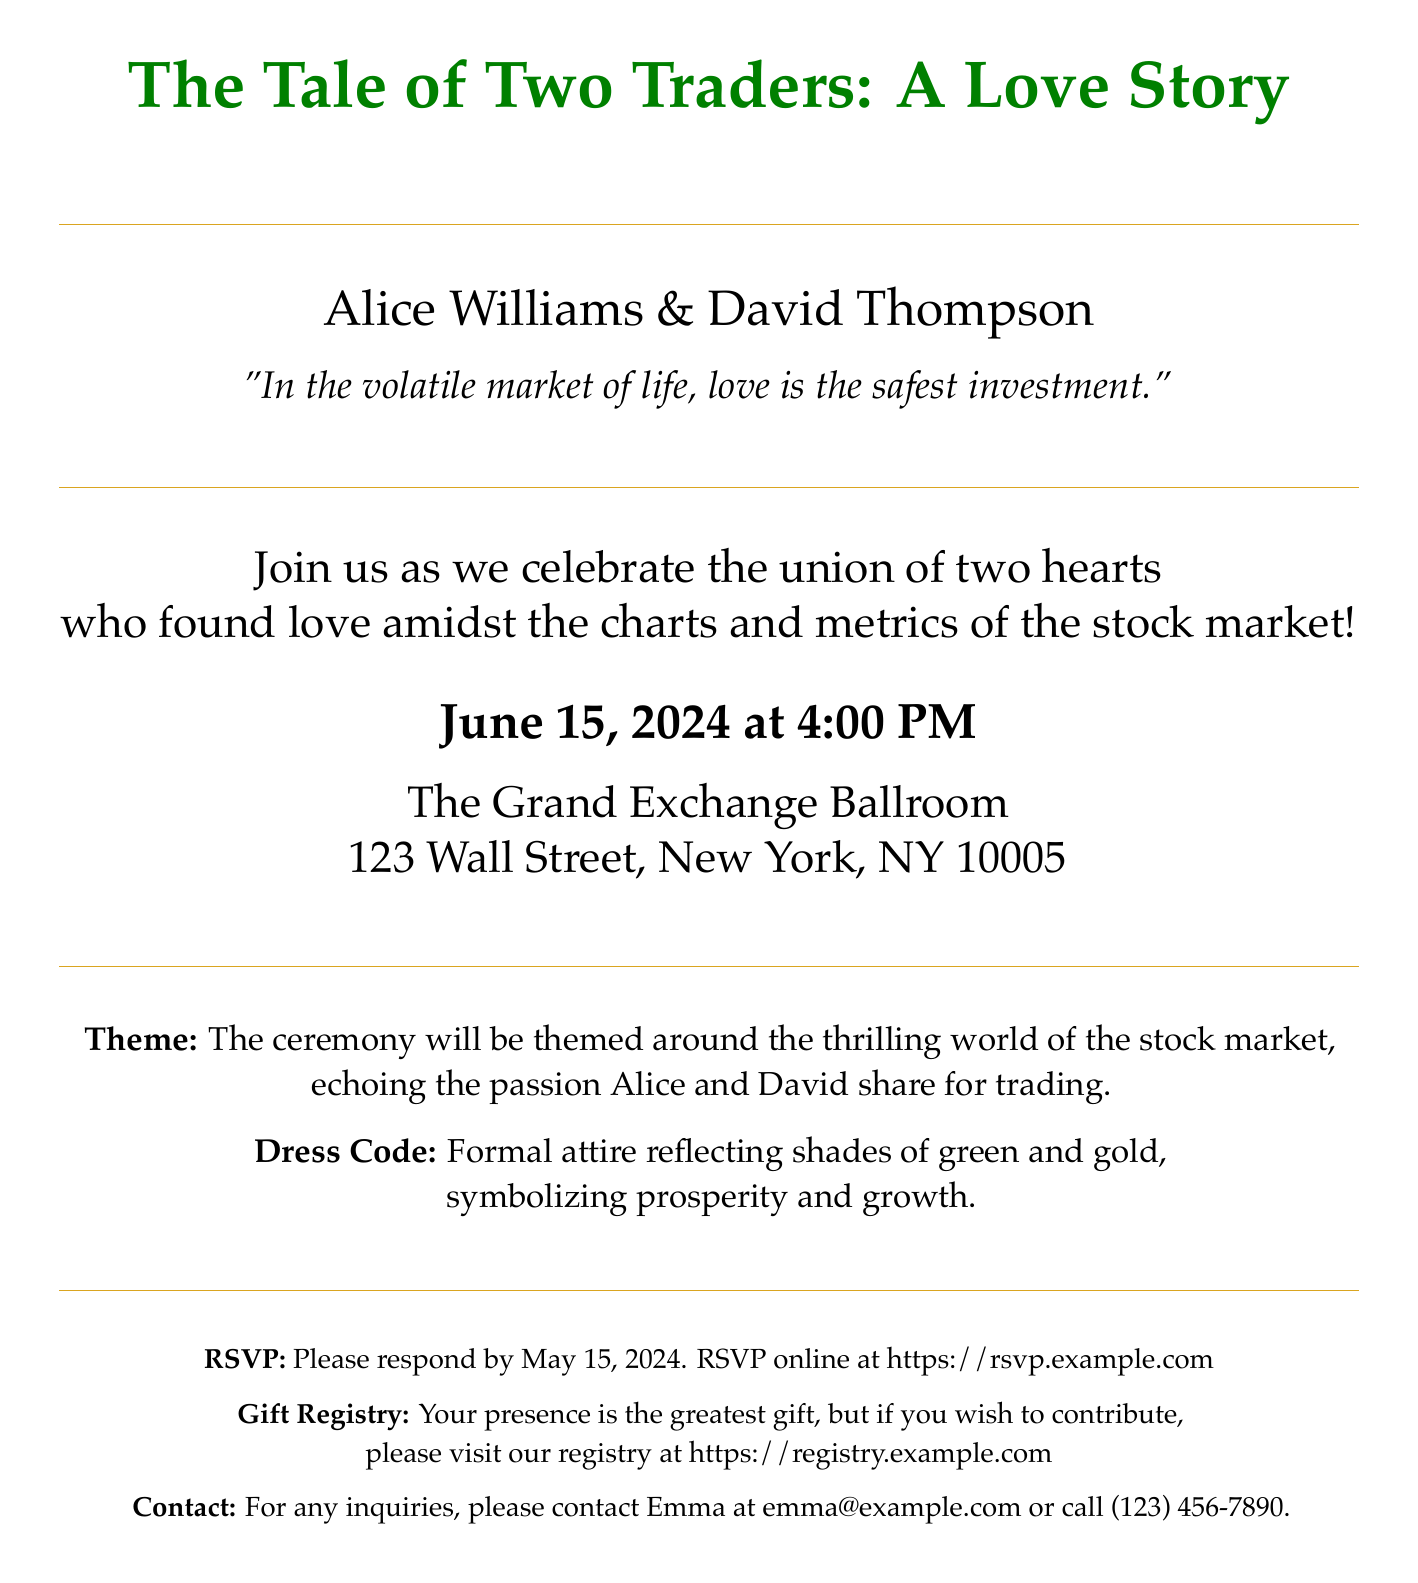What is the name of the bride? The bride's name is mentioned at the top of the invitation as Alice Williams.
Answer: Alice Williams What is the date of the wedding? The wedding date is specified in the document. It states June 15, 2024.
Answer: June 15, 2024 What is the location of the ceremony? The invitation provides the address for the ceremony, which is The Grand Exchange Ballroom, 123 Wall Street, New York, NY 10005.
Answer: The Grand Exchange Ballroom, 123 Wall Street, New York, NY 10005 What is the theme of the wedding? The theme is described in a specific section, emphasizing the world of the stock market.
Answer: The thrilling world of the stock market What is the dress code? The document states that the dress code should reflect shades of green and gold.
Answer: Formal attire reflecting shades of green and gold What is the gift registry link? The invitation mentions a gift registry and provides the link.
Answer: https://registry.example.com By what date should guests RSVP? The RSVP date is clearly indicated as May 15, 2024.
Answer: May 15, 2024 Who should inquiries be directed to? The contact for inquiries is specified as Emma, along with her email and phone number.
Answer: Emma What is the quote included in the invitation? A quote expressing the couple's sentiment is included in the document.
Answer: "In the volatile market of life, love is the safest investment." 